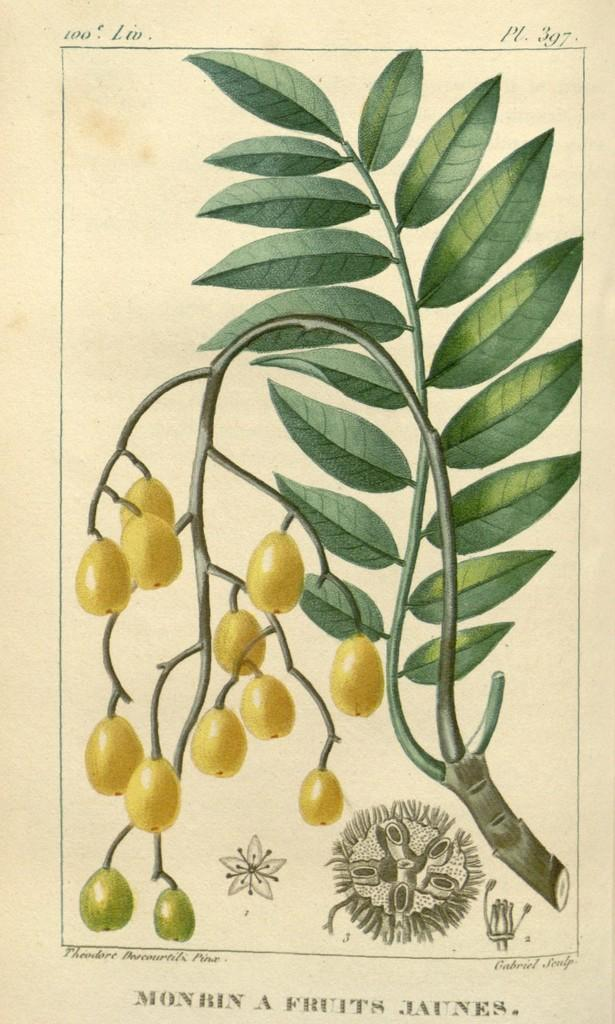What is depicted on the paper in the image? There is a paper with fruits depicted on it, along with stems and leaves. Are there any additional elements on the paper? Yes, there are designs present on the paper. Is there any text on the paper? Yes, there is text on the paper. What type of war is being discussed in the text on the paper? There is no mention of war in the text on the paper; it focuses on fruits, stems, and leaves. Does the paper acknowledge the existence of good-bye in its text? There is no mention of good-bye in the text on the paper; it focuses on fruits, stems, and leaves. 